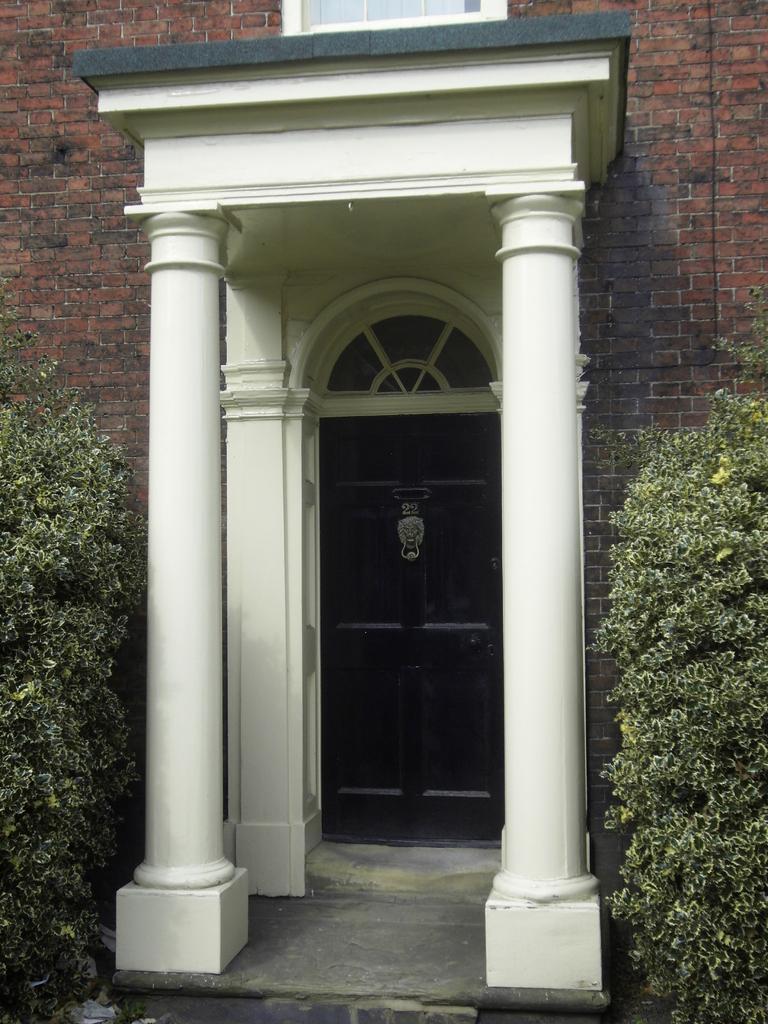In one or two sentences, can you explain what this image depicts? In the center of the image there is a building. There is a arch. There is a door. At the right side of the image there are plants and at the left side of the image there are plants. 